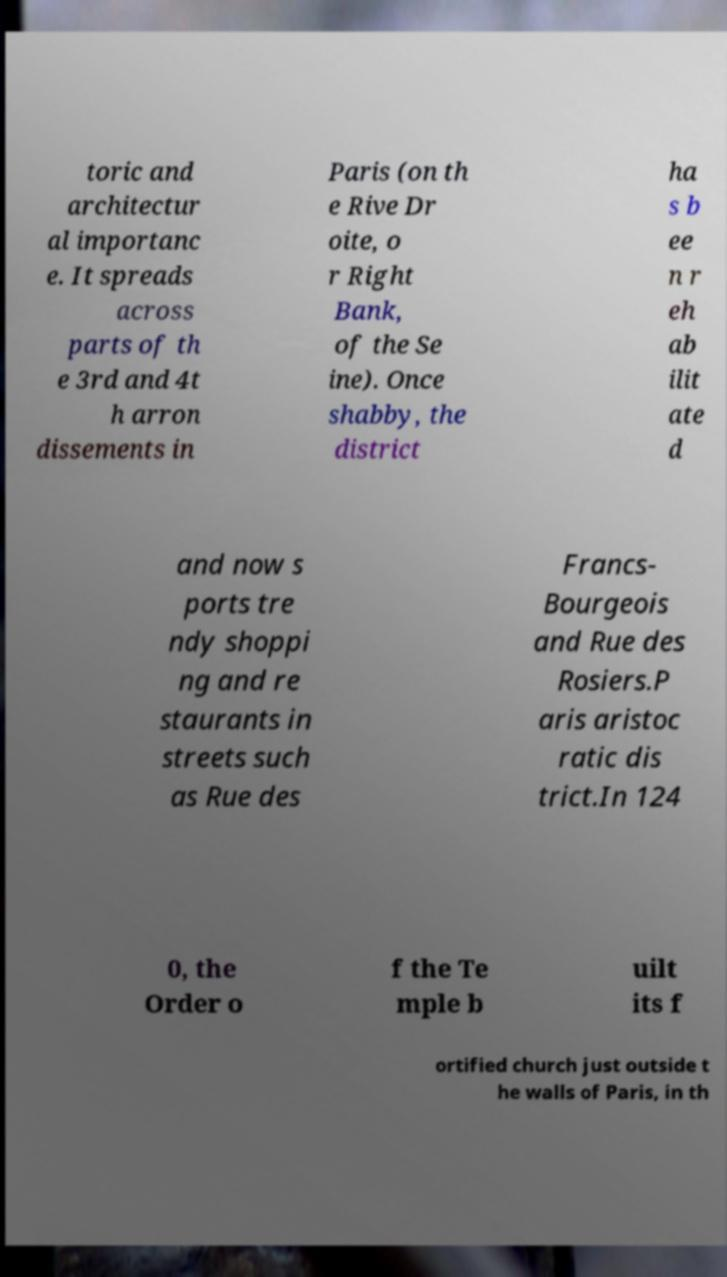What messages or text are displayed in this image? I need them in a readable, typed format. toric and architectur al importanc e. It spreads across parts of th e 3rd and 4t h arron dissements in Paris (on th e Rive Dr oite, o r Right Bank, of the Se ine). Once shabby, the district ha s b ee n r eh ab ilit ate d and now s ports tre ndy shoppi ng and re staurants in streets such as Rue des Francs- Bourgeois and Rue des Rosiers.P aris aristoc ratic dis trict.In 124 0, the Order o f the Te mple b uilt its f ortified church just outside t he walls of Paris, in th 